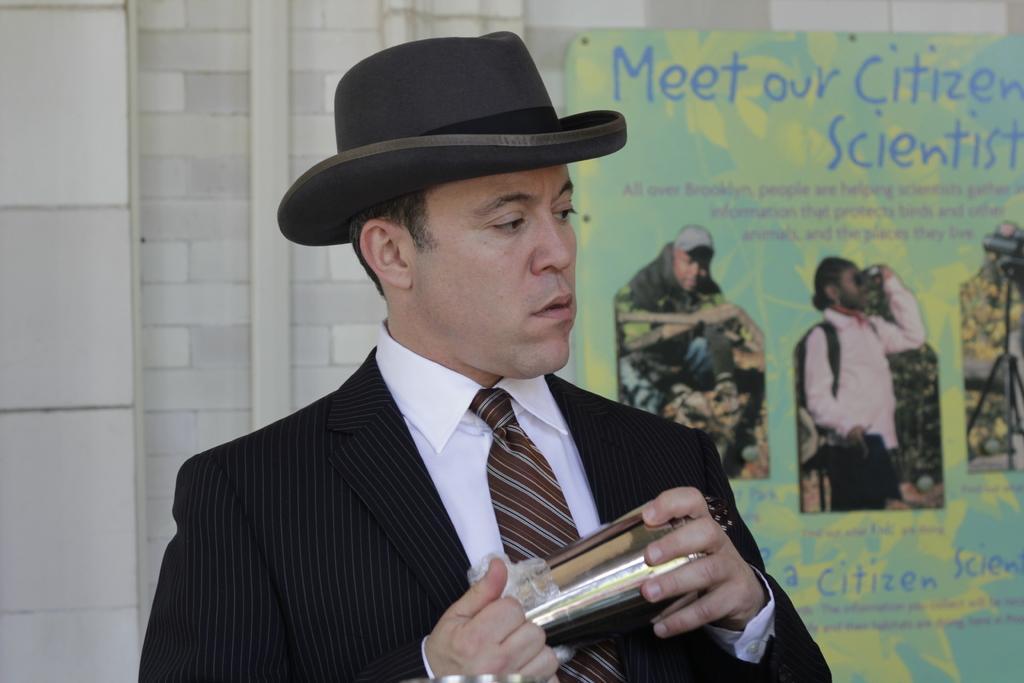In one or two sentences, can you explain what this image depicts? In the center of the image there is a person wearing a hat. In the background there is a poster and wall. 